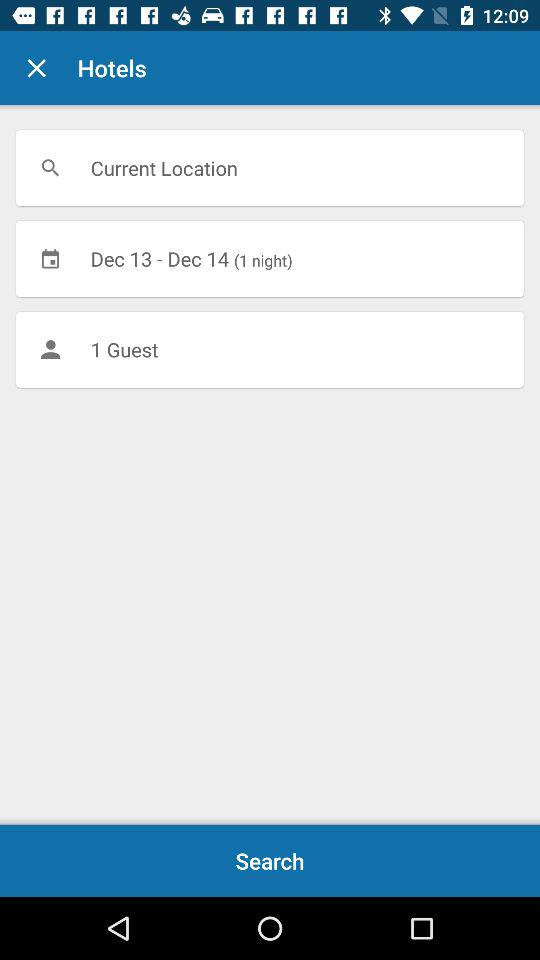What is the number of guests? The number of guests is 1. 